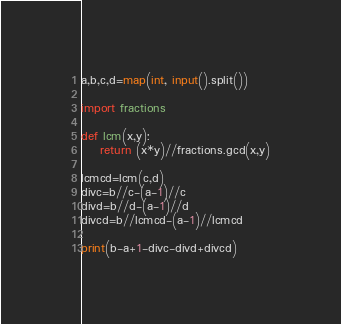<code> <loc_0><loc_0><loc_500><loc_500><_Python_>a,b,c,d=map(int, input().split())

import fractions

def lcm(x,y):
	return (x*y)//fractions.gcd(x,y)

lcmcd=lcm(c,d)
divc=b//c-(a-1)//c
divd=b//d-(a-1)//d
divcd=b//lcmcd-(a-1)//lcmcd

print(b-a+1-divc-divd+divcd)</code> 